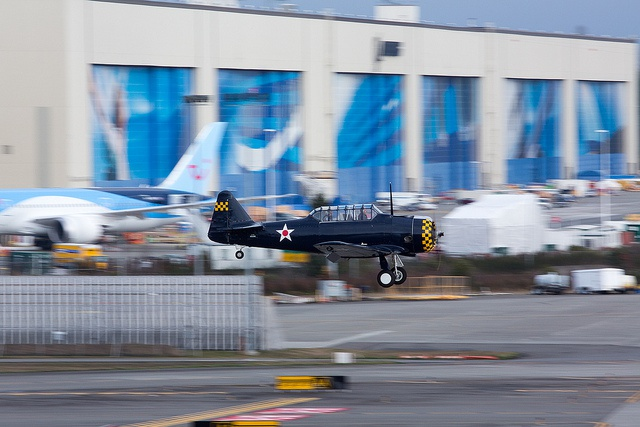Describe the objects in this image and their specific colors. I can see airplane in lightgray, lavender, lightblue, darkgray, and gray tones, airplane in lightgray, black, navy, gray, and darkgray tones, truck in lightgray, gray, and darkgray tones, and people in lightgray, gray, and lightpink tones in this image. 